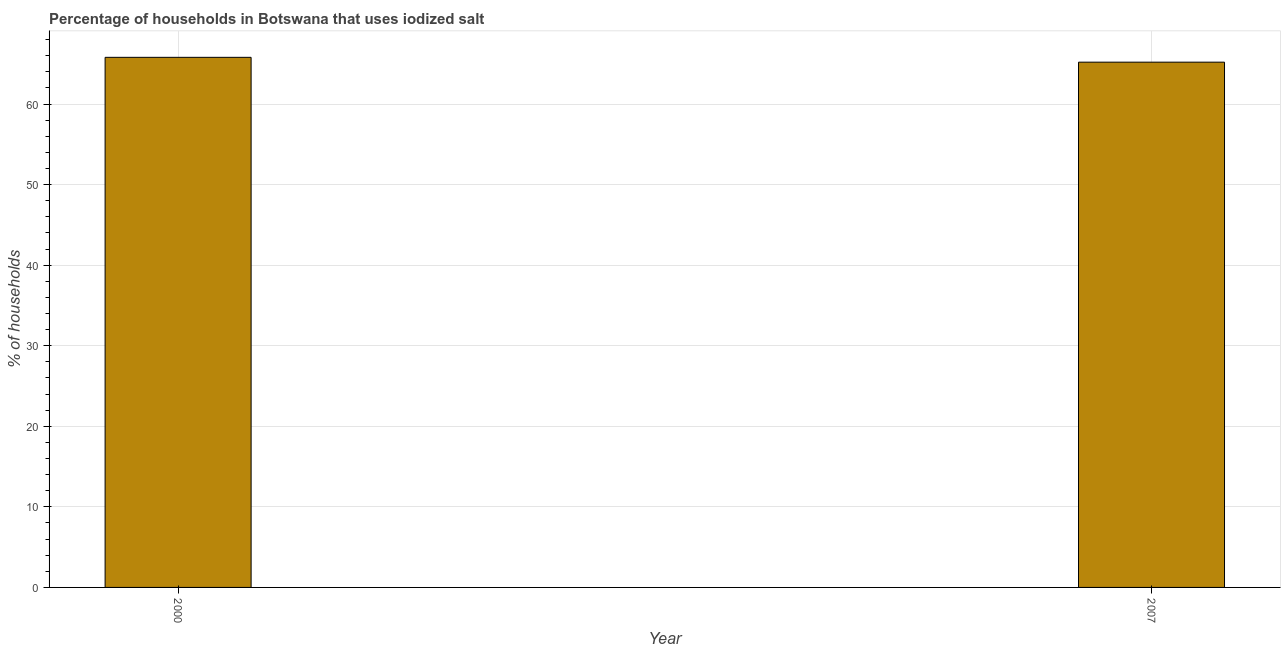Does the graph contain any zero values?
Offer a terse response. No. What is the title of the graph?
Keep it short and to the point. Percentage of households in Botswana that uses iodized salt. What is the label or title of the X-axis?
Give a very brief answer. Year. What is the label or title of the Y-axis?
Your answer should be compact. % of households. What is the percentage of households where iodized salt is consumed in 2000?
Offer a very short reply. 65.8. Across all years, what is the maximum percentage of households where iodized salt is consumed?
Ensure brevity in your answer.  65.8. Across all years, what is the minimum percentage of households where iodized salt is consumed?
Keep it short and to the point. 65.2. In which year was the percentage of households where iodized salt is consumed maximum?
Provide a short and direct response. 2000. In which year was the percentage of households where iodized salt is consumed minimum?
Your answer should be very brief. 2007. What is the sum of the percentage of households where iodized salt is consumed?
Provide a short and direct response. 131. What is the difference between the percentage of households where iodized salt is consumed in 2000 and 2007?
Keep it short and to the point. 0.6. What is the average percentage of households where iodized salt is consumed per year?
Provide a succinct answer. 65.5. What is the median percentage of households where iodized salt is consumed?
Your response must be concise. 65.5. In how many years, is the percentage of households where iodized salt is consumed greater than 6 %?
Give a very brief answer. 2. What is the ratio of the percentage of households where iodized salt is consumed in 2000 to that in 2007?
Provide a short and direct response. 1.01. Is the percentage of households where iodized salt is consumed in 2000 less than that in 2007?
Ensure brevity in your answer.  No. In how many years, is the percentage of households where iodized salt is consumed greater than the average percentage of households where iodized salt is consumed taken over all years?
Your answer should be very brief. 1. How many years are there in the graph?
Ensure brevity in your answer.  2. What is the difference between two consecutive major ticks on the Y-axis?
Your answer should be compact. 10. What is the % of households of 2000?
Offer a terse response. 65.8. What is the % of households in 2007?
Keep it short and to the point. 65.2. What is the difference between the % of households in 2000 and 2007?
Give a very brief answer. 0.6. 